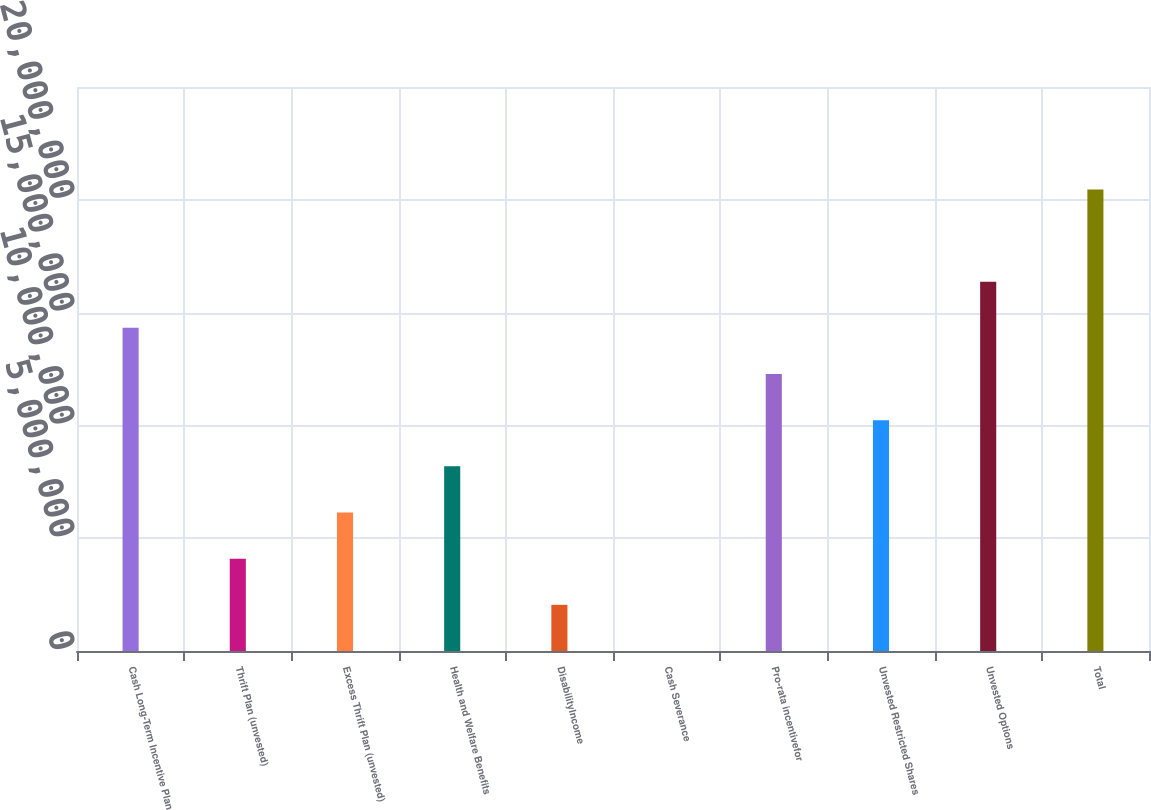<chart> <loc_0><loc_0><loc_500><loc_500><bar_chart><fcel>Cash Long-Term Incentive Plan<fcel>Thrift Plan (unvested)<fcel>Excess Thrift Plan (unvested)<fcel>Health and Welfare Benefits<fcel>DisabilityIncome<fcel>Cash Severance<fcel>Pro-rata incentivefor<fcel>Unvested Restricted Shares<fcel>Unvested Options<fcel>Total<nl><fcel>1.43233e+07<fcel>4.09238e+06<fcel>6.13857e+06<fcel>8.18476e+06<fcel>2.04619e+06<fcel>0.85<fcel>1.22771e+07<fcel>1.02309e+07<fcel>1.63695e+07<fcel>2.04619e+07<nl></chart> 